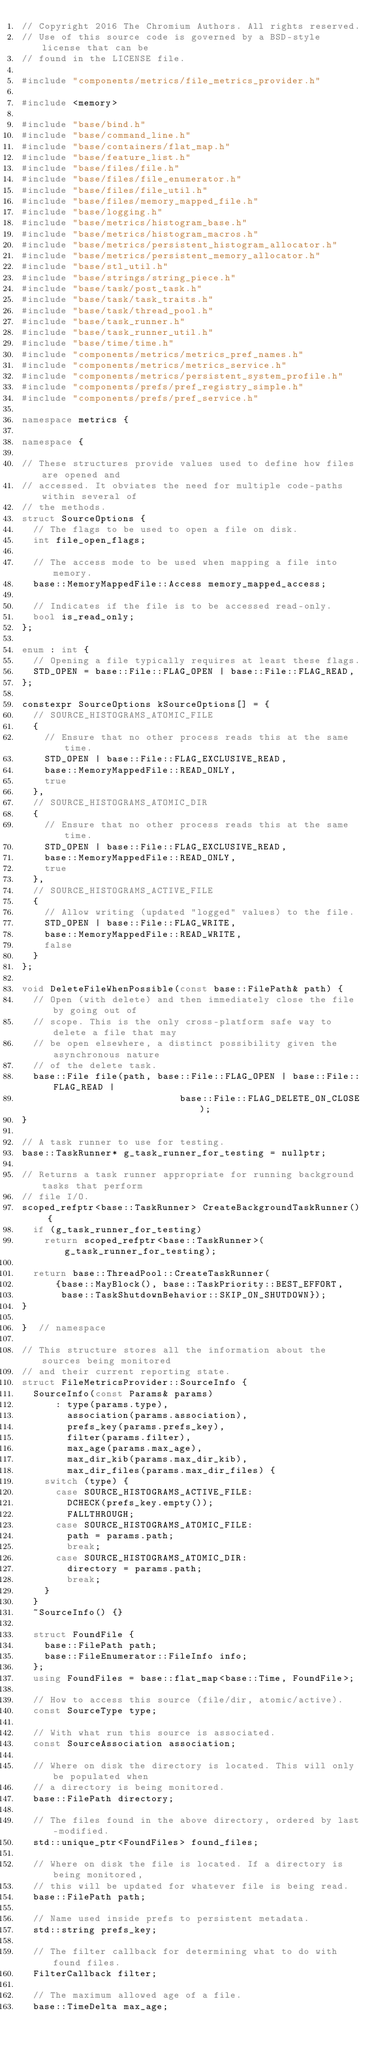Convert code to text. <code><loc_0><loc_0><loc_500><loc_500><_C++_>// Copyright 2016 The Chromium Authors. All rights reserved.
// Use of this source code is governed by a BSD-style license that can be
// found in the LICENSE file.

#include "components/metrics/file_metrics_provider.h"

#include <memory>

#include "base/bind.h"
#include "base/command_line.h"
#include "base/containers/flat_map.h"
#include "base/feature_list.h"
#include "base/files/file.h"
#include "base/files/file_enumerator.h"
#include "base/files/file_util.h"
#include "base/files/memory_mapped_file.h"
#include "base/logging.h"
#include "base/metrics/histogram_base.h"
#include "base/metrics/histogram_macros.h"
#include "base/metrics/persistent_histogram_allocator.h"
#include "base/metrics/persistent_memory_allocator.h"
#include "base/stl_util.h"
#include "base/strings/string_piece.h"
#include "base/task/post_task.h"
#include "base/task/task_traits.h"
#include "base/task/thread_pool.h"
#include "base/task_runner.h"
#include "base/task_runner_util.h"
#include "base/time/time.h"
#include "components/metrics/metrics_pref_names.h"
#include "components/metrics/metrics_service.h"
#include "components/metrics/persistent_system_profile.h"
#include "components/prefs/pref_registry_simple.h"
#include "components/prefs/pref_service.h"

namespace metrics {

namespace {

// These structures provide values used to define how files are opened and
// accessed. It obviates the need for multiple code-paths within several of
// the methods.
struct SourceOptions {
  // The flags to be used to open a file on disk.
  int file_open_flags;

  // The access mode to be used when mapping a file into memory.
  base::MemoryMappedFile::Access memory_mapped_access;

  // Indicates if the file is to be accessed read-only.
  bool is_read_only;
};

enum : int {
  // Opening a file typically requires at least these flags.
  STD_OPEN = base::File::FLAG_OPEN | base::File::FLAG_READ,
};

constexpr SourceOptions kSourceOptions[] = {
  // SOURCE_HISTOGRAMS_ATOMIC_FILE
  {
    // Ensure that no other process reads this at the same time.
    STD_OPEN | base::File::FLAG_EXCLUSIVE_READ,
    base::MemoryMappedFile::READ_ONLY,
    true
  },
  // SOURCE_HISTOGRAMS_ATOMIC_DIR
  {
    // Ensure that no other process reads this at the same time.
    STD_OPEN | base::File::FLAG_EXCLUSIVE_READ,
    base::MemoryMappedFile::READ_ONLY,
    true
  },
  // SOURCE_HISTOGRAMS_ACTIVE_FILE
  {
    // Allow writing (updated "logged" values) to the file.
    STD_OPEN | base::File::FLAG_WRITE,
    base::MemoryMappedFile::READ_WRITE,
    false
  }
};

void DeleteFileWhenPossible(const base::FilePath& path) {
  // Open (with delete) and then immediately close the file by going out of
  // scope. This is the only cross-platform safe way to delete a file that may
  // be open elsewhere, a distinct possibility given the asynchronous nature
  // of the delete task.
  base::File file(path, base::File::FLAG_OPEN | base::File::FLAG_READ |
                            base::File::FLAG_DELETE_ON_CLOSE);
}

// A task runner to use for testing.
base::TaskRunner* g_task_runner_for_testing = nullptr;

// Returns a task runner appropriate for running background tasks that perform
// file I/O.
scoped_refptr<base::TaskRunner> CreateBackgroundTaskRunner() {
  if (g_task_runner_for_testing)
    return scoped_refptr<base::TaskRunner>(g_task_runner_for_testing);

  return base::ThreadPool::CreateTaskRunner(
      {base::MayBlock(), base::TaskPriority::BEST_EFFORT,
       base::TaskShutdownBehavior::SKIP_ON_SHUTDOWN});
}

}  // namespace

// This structure stores all the information about the sources being monitored
// and their current reporting state.
struct FileMetricsProvider::SourceInfo {
  SourceInfo(const Params& params)
      : type(params.type),
        association(params.association),
        prefs_key(params.prefs_key),
        filter(params.filter),
        max_age(params.max_age),
        max_dir_kib(params.max_dir_kib),
        max_dir_files(params.max_dir_files) {
    switch (type) {
      case SOURCE_HISTOGRAMS_ACTIVE_FILE:
        DCHECK(prefs_key.empty());
        FALLTHROUGH;
      case SOURCE_HISTOGRAMS_ATOMIC_FILE:
        path = params.path;
        break;
      case SOURCE_HISTOGRAMS_ATOMIC_DIR:
        directory = params.path;
        break;
    }
  }
  ~SourceInfo() {}

  struct FoundFile {
    base::FilePath path;
    base::FileEnumerator::FileInfo info;
  };
  using FoundFiles = base::flat_map<base::Time, FoundFile>;

  // How to access this source (file/dir, atomic/active).
  const SourceType type;

  // With what run this source is associated.
  const SourceAssociation association;

  // Where on disk the directory is located. This will only be populated when
  // a directory is being monitored.
  base::FilePath directory;

  // The files found in the above directory, ordered by last-modified.
  std::unique_ptr<FoundFiles> found_files;

  // Where on disk the file is located. If a directory is being monitored,
  // this will be updated for whatever file is being read.
  base::FilePath path;

  // Name used inside prefs to persistent metadata.
  std::string prefs_key;

  // The filter callback for determining what to do with found files.
  FilterCallback filter;

  // The maximum allowed age of a file.
  base::TimeDelta max_age;
</code> 